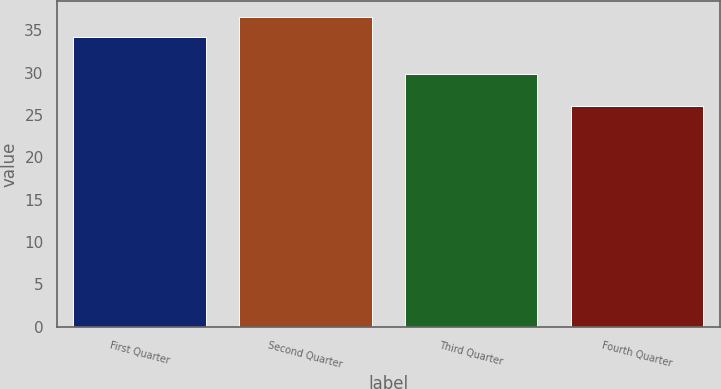Convert chart to OTSL. <chart><loc_0><loc_0><loc_500><loc_500><bar_chart><fcel>First Quarter<fcel>Second Quarter<fcel>Third Quarter<fcel>Fourth Quarter<nl><fcel>34.18<fcel>36.61<fcel>29.89<fcel>26.07<nl></chart> 